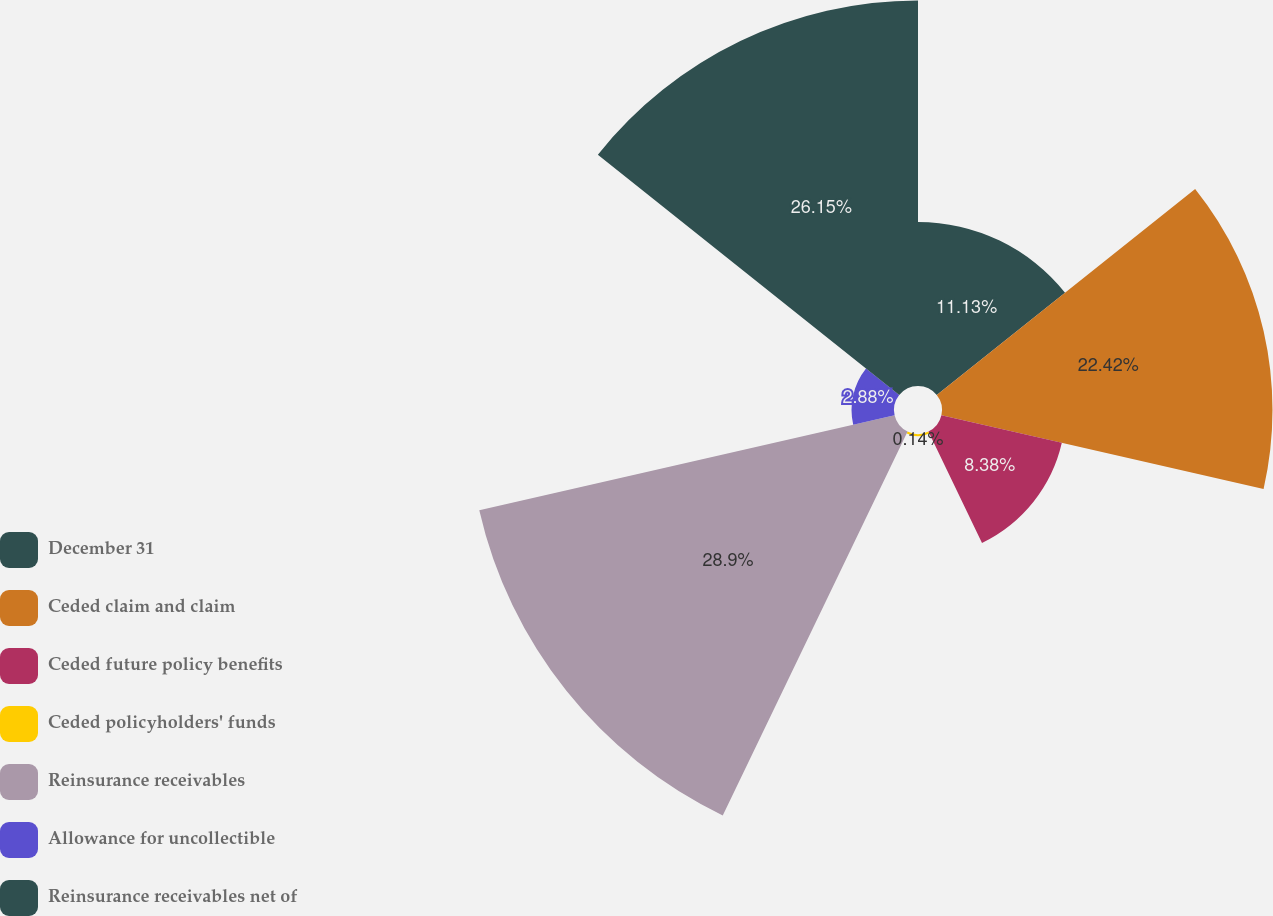<chart> <loc_0><loc_0><loc_500><loc_500><pie_chart><fcel>December 31<fcel>Ceded claim and claim<fcel>Ceded future policy benefits<fcel>Ceded policyholders' funds<fcel>Reinsurance receivables<fcel>Allowance for uncollectible<fcel>Reinsurance receivables net of<nl><fcel>11.13%<fcel>22.42%<fcel>8.38%<fcel>0.14%<fcel>28.9%<fcel>2.88%<fcel>26.15%<nl></chart> 